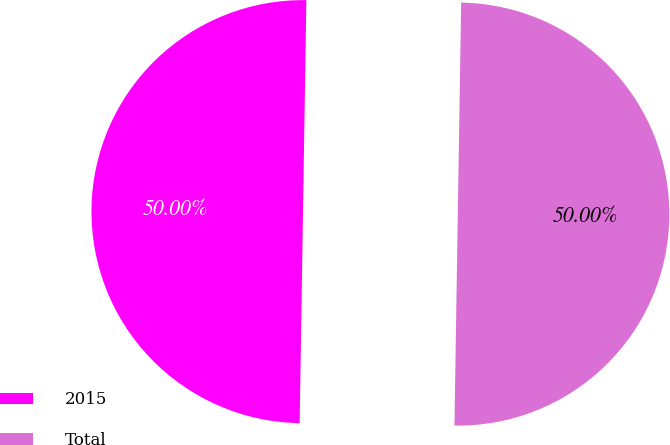<chart> <loc_0><loc_0><loc_500><loc_500><pie_chart><fcel>2015<fcel>Total<nl><fcel>50.0%<fcel>50.0%<nl></chart> 